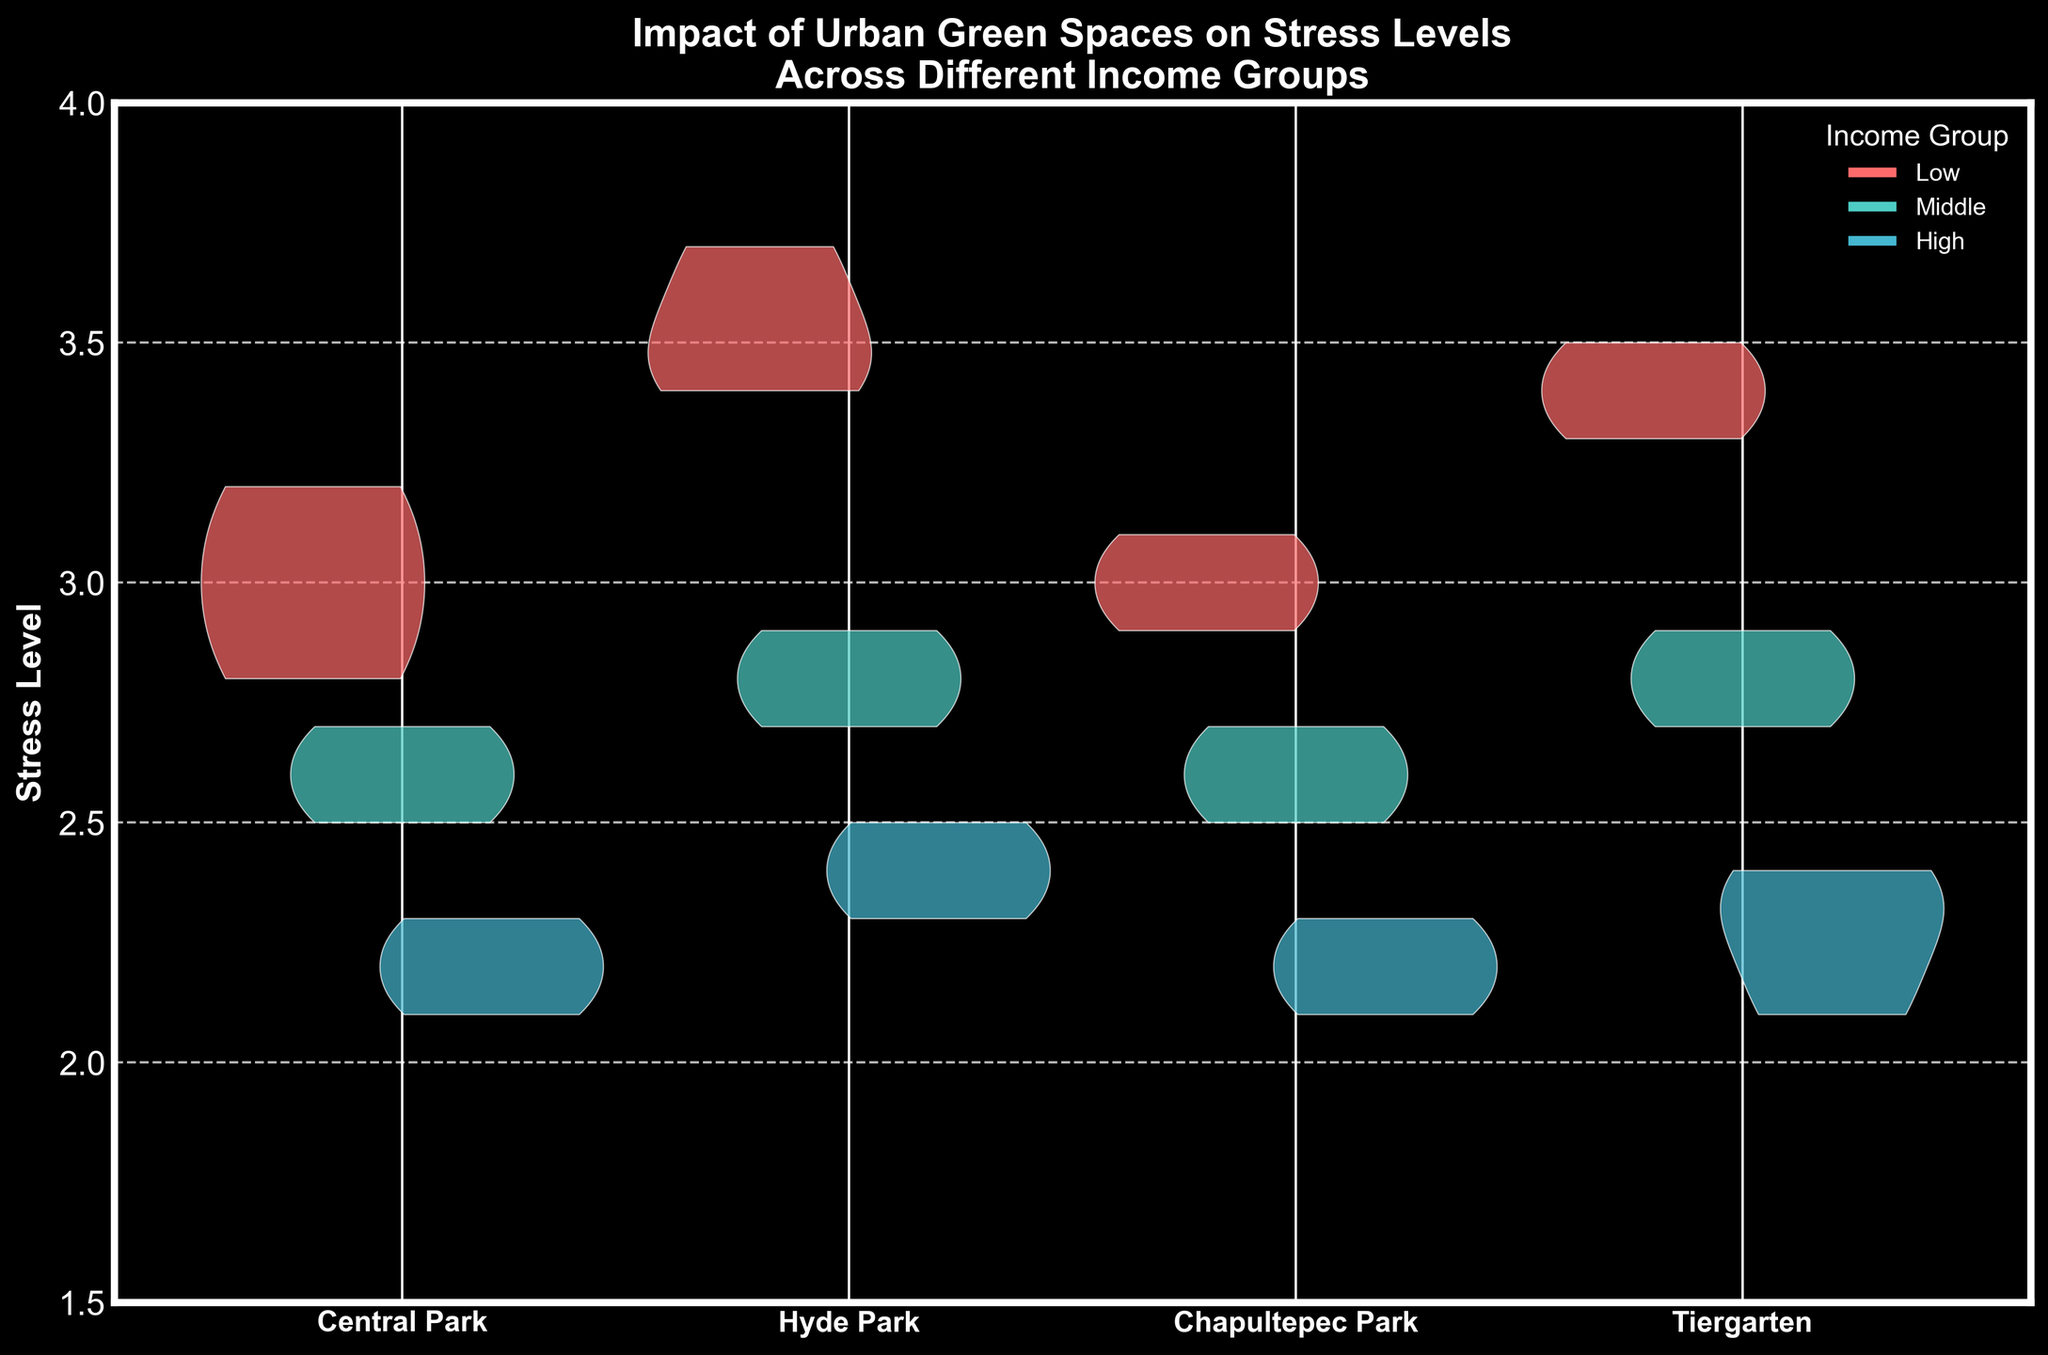What is the title of the figure? The title of the figure is located above the chart and typically summarizes what the chart represents.
Answer: Impact of Urban Green Spaces on Stress Levels Across Different Income Groups Which income group shows the highest stress levels in Central Park? By observing the left side of the split violin plot for Central Park, we can see which income group has the highest stress levels. The left-most group represents the "Low" income group.
Answer: Low What colors correspond to the different income groups? Refer to the legend on the figure, which maps the income groups to specific colors.
Answer: Low income is red, Middle income is turquoise, and High income is light blue What is the range of stress levels on the y-axis? The y-axis shows the range of data for stress levels, marked from the lowest to the highest value.
Answer: 1.5 to 4 Which park shows the lowest median stress levels for the High income group? By comparing the spread of the violin plots for the High income group across the parks, the park with the narrowest and lowest spread at the center signifies the lowest median stress level.
Answer: Central Park For which income group do urban green spaces seem to reduce stress levels the most? Compare the central tendency (middle of the violin plots) and the spread across all parks for each income group. The High income group shows the most significant reduction in stress levels in all parks.
Answer: High Between Hyde Park and Tiergarten, which one shows a greater reduction in stress levels from Low to High income groups? Compare the difference in the center of the violin plots for Low and High income groups in both Hyde Park and Tiergarten. The larger gap indicates a greater reduction.
Answer: Hyde Park Which park has the most similar stress level distributions across all income groups? Look for the park where the shapes and ranges of the violin plots for Low, Middle, and High income groups are most similar.
Answer: Chapultepec Park What is the common stress level range for low income groups across all parks? Observe the vertical range of the violin plots for Low income group, and note the common stress level where all violins overlap.
Answer: 3.0 to 3.5 What might you infer about the relationship between income level and stress reduction in urban green spaces? The trend across different parks shows that as income level increases, stress levels tend to decrease, indicating a possible correlation where higher income individuals benefit more from urban green spaces in terms of stress reduction.
Answer: Higher income levels correlate with lower stress levels in green spaces 